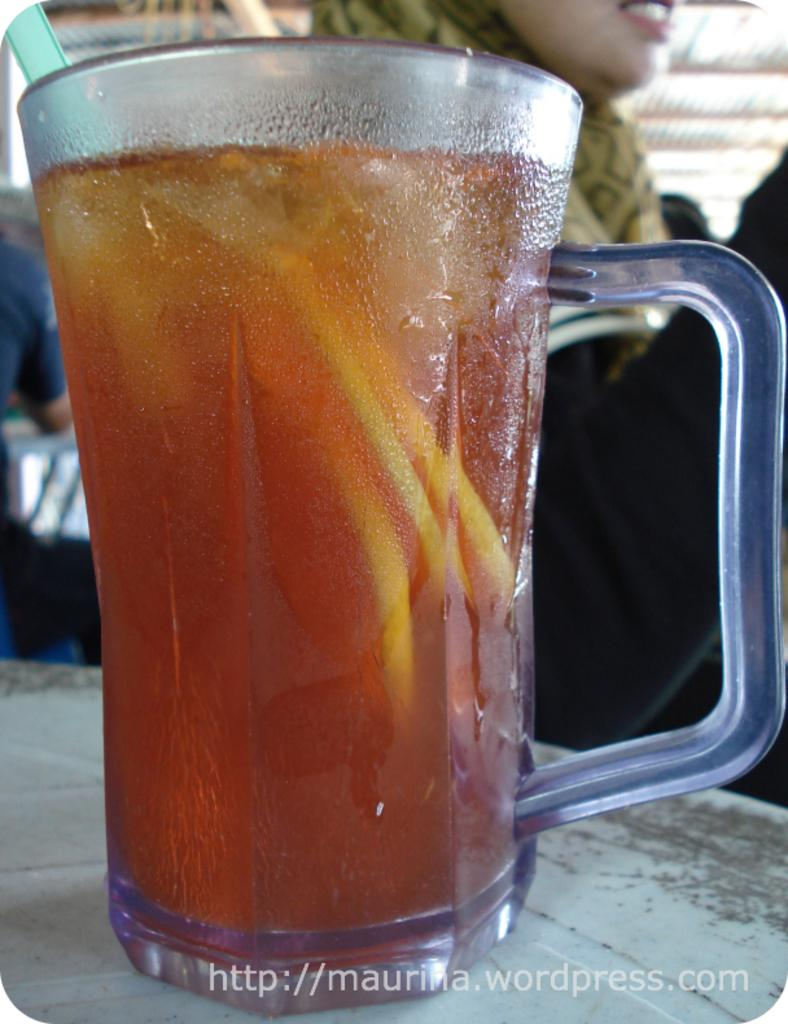What is in the glass that is visible in the image? There is a glass of liquid in the image. How is the liquid being consumed in the image? The glass has a straw in it, which suggests that the liquid is being sipped through the straw. Where is the glass located in the image? The glass is on a table. Can you describe the woman in the background of the image? The provided facts do not give any details about the woman in the background, so we cannot describe her. What is written at the bottom of the image? There is text at the bottom of the image. What type of metal is the wool used in the image? There is no wool present in the image, and therefore no metal associated with it. 